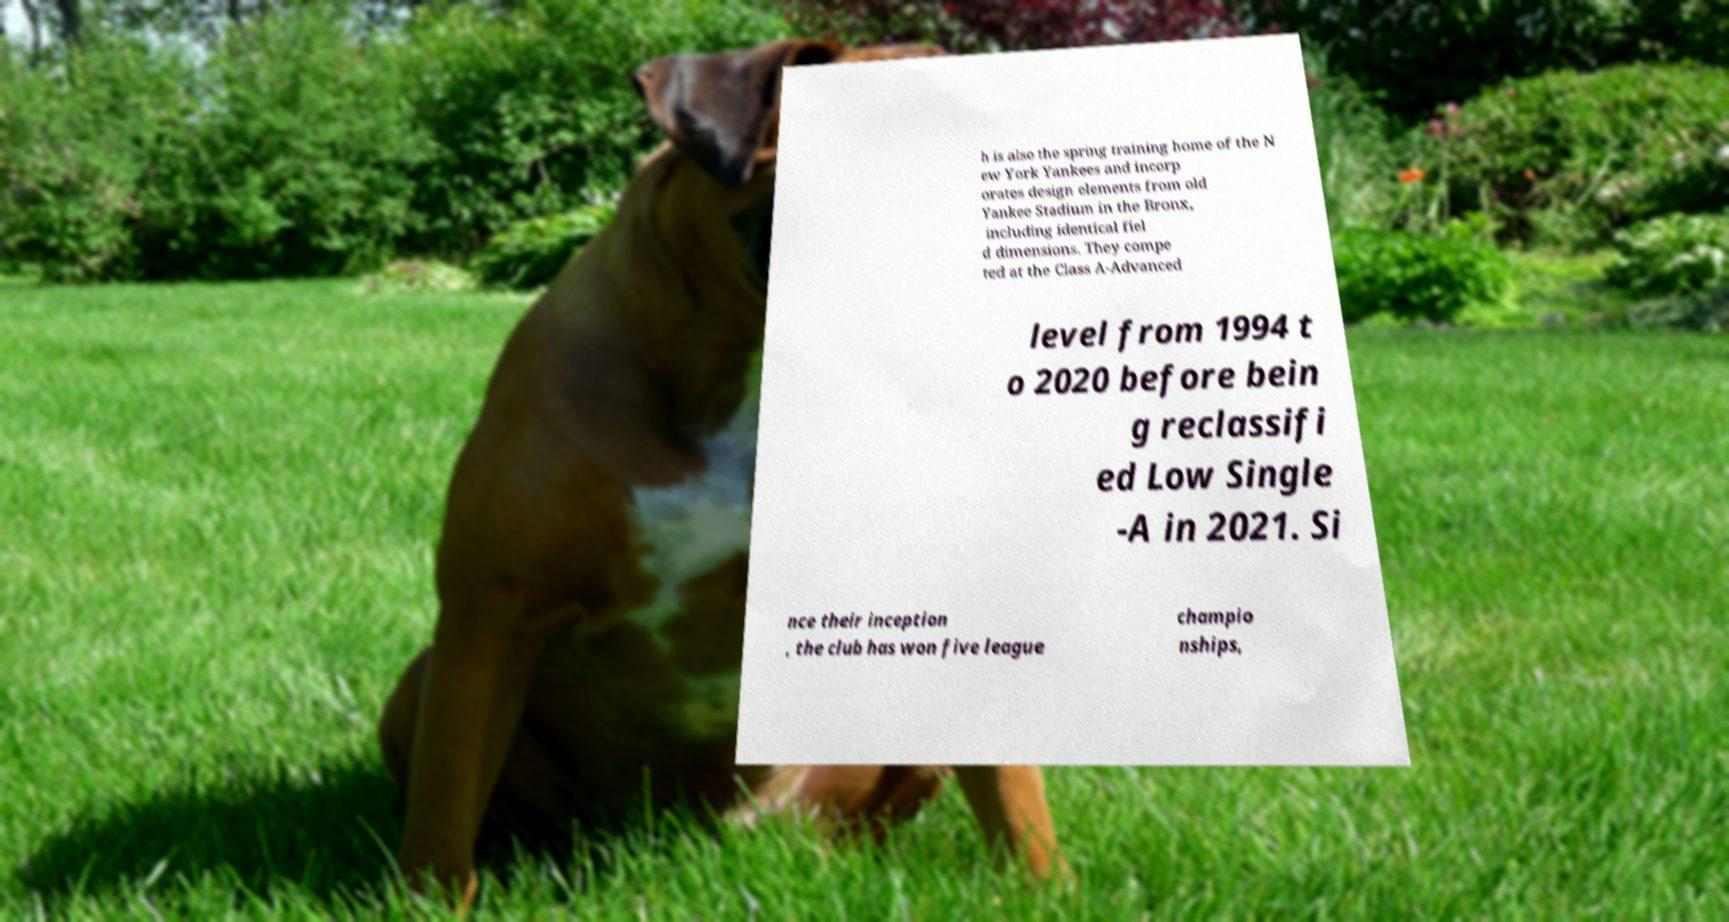Please identify and transcribe the text found in this image. h is also the spring training home of the N ew York Yankees and incorp orates design elements from old Yankee Stadium in the Bronx, including identical fiel d dimensions. They compe ted at the Class A-Advanced level from 1994 t o 2020 before bein g reclassifi ed Low Single -A in 2021. Si nce their inception , the club has won five league champio nships, 